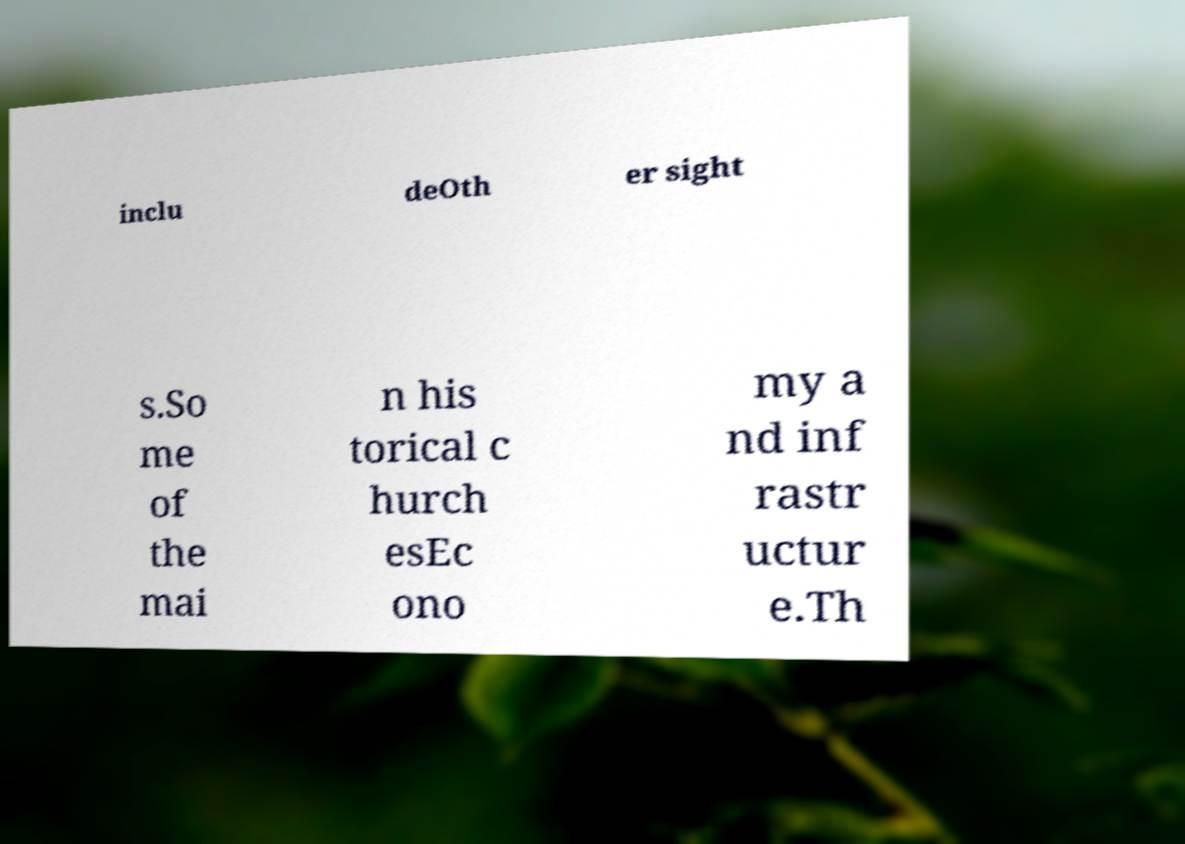What messages or text are displayed in this image? I need them in a readable, typed format. inclu deOth er sight s.So me of the mai n his torical c hurch esEc ono my a nd inf rastr uctur e.Th 